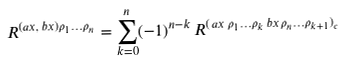<formula> <loc_0><loc_0><loc_500><loc_500>R ^ { ( a x , \, b x ) \rho _ { 1 } \dots \rho _ { n } } = \sum _ { k = 0 } ^ { n } ( - 1 ) ^ { n - k } \, R ^ { ( \, a x \, \rho _ { 1 } \dots \rho _ { k } \, b x \, \rho _ { n } \dots \rho _ { k + 1 } ) _ { c } }</formula> 